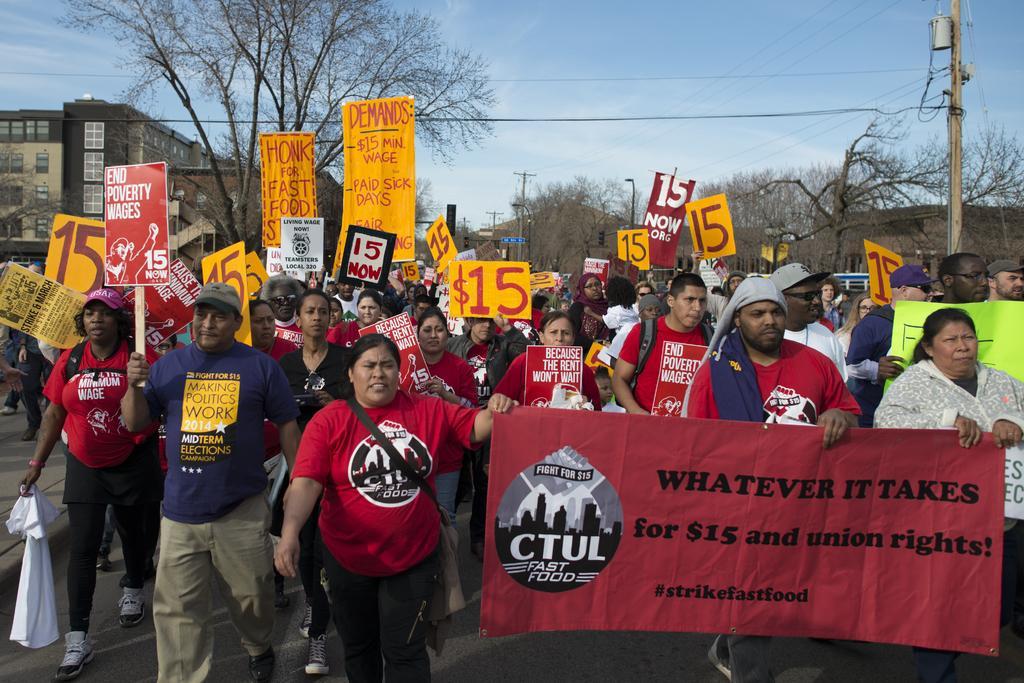How would you summarize this image in a sentence or two? This picture describe about the group of people wearing red color t- shirt and walking on the road for the protest. In front we can see red color banner. Behind we can see yellow color boards in the hand. In the background some trees and on the left side we can see the building with white windows. 